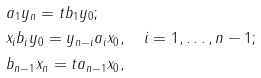Convert formula to latex. <formula><loc_0><loc_0><loc_500><loc_500>& a _ { 1 } y _ { n } = t b _ { 1 } y _ { 0 } ; \\ & x _ { i } b _ { i } y _ { 0 } = y _ { n - i } a _ { i } x _ { 0 } , \quad i = 1 , \dots , n - 1 ; \\ & b _ { n - 1 } x _ { n } = t a _ { n - 1 } x _ { 0 } ,</formula> 